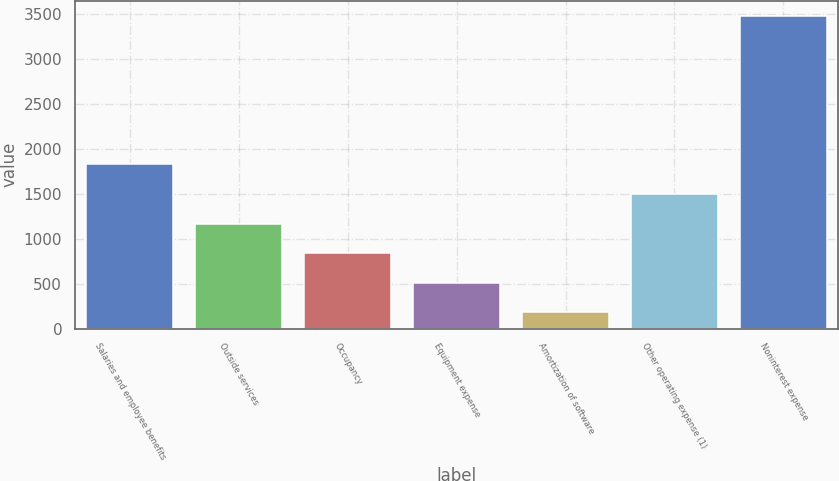Convert chart to OTSL. <chart><loc_0><loc_0><loc_500><loc_500><bar_chart><fcel>Salaries and employee benefits<fcel>Outside services<fcel>Occupancy<fcel>Equipment expense<fcel>Amortization of software<fcel>Other operating expense (1)<fcel>Noninterest expense<nl><fcel>1827<fcel>1168.2<fcel>838.8<fcel>509.4<fcel>180<fcel>1497.6<fcel>3474<nl></chart> 